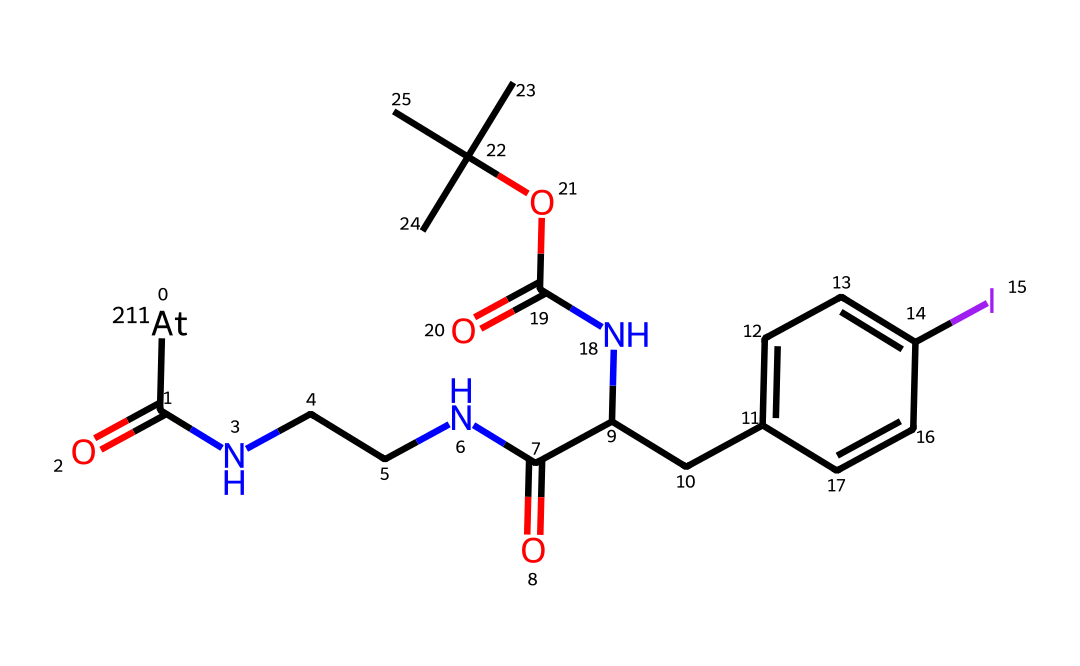What is the primary halogen present in this compound? The compound contains astatine as evidenced by the mention of [211At] in the SMILES representation, indicating that astatine is the isotope present.
Answer: astatine How many carbon atoms are in the structure? By analyzing the SMILES, we count the number of 'C' symbols, which represent carbon atoms. There are 12 carbon atoms in the entire structure.
Answer: 12 What type of bonding is present in the carbonyl group? The carbonyl group (C=O) features a double bond between the carbon and oxygen atoms, indicative of a ketone or amide type of bond in this context.
Answer: double bond Does this compound contain any amine functional groups? The structure includes multiple instances of -NH groups (notated by 'N' surrounded by carbon atoms), indicating the presence of amine functional groups in its design, specifically in the interactions with other groups.
Answer: yes What is the overall charge of astatine in this compound? Given that astatine is presented as [211At], it indicates that it is in a neutral state within the structure; thus, the charge is neutral.
Answer: neutral What rings are present in the structure? The chemical structure reveals a benzene ring, which can be identified by the pattern of alternating single and double bonds connected in a cyclic form, specifically represented by "C(C1=CC=C(I)C=C1)".
Answer: benzene ring What purpose might this compound serve in cancer therapy? This compound's design includes a targeting component that interacts with nitrogenous bases typical in biological systems, making it plausible for applications in targeted cancer therapies, particularly in modulating cell activity.
Answer: targeted therapy 